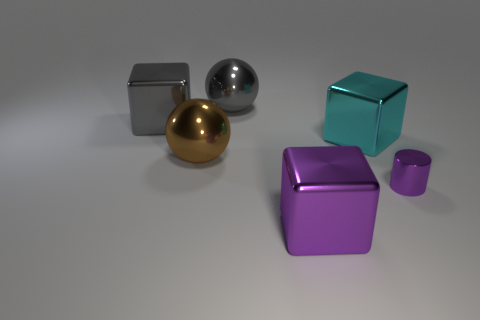Subtract all large gray cubes. How many cubes are left? 2 Add 2 gray metal blocks. How many objects exist? 8 Subtract all brown spheres. How many spheres are left? 1 Subtract 0 yellow balls. How many objects are left? 6 Subtract all spheres. How many objects are left? 4 Subtract 1 balls. How many balls are left? 1 Subtract all cyan cylinders. Subtract all red cubes. How many cylinders are left? 1 Subtract all yellow cylinders. How many gray spheres are left? 1 Subtract all big cyan matte blocks. Subtract all purple blocks. How many objects are left? 5 Add 1 cylinders. How many cylinders are left? 2 